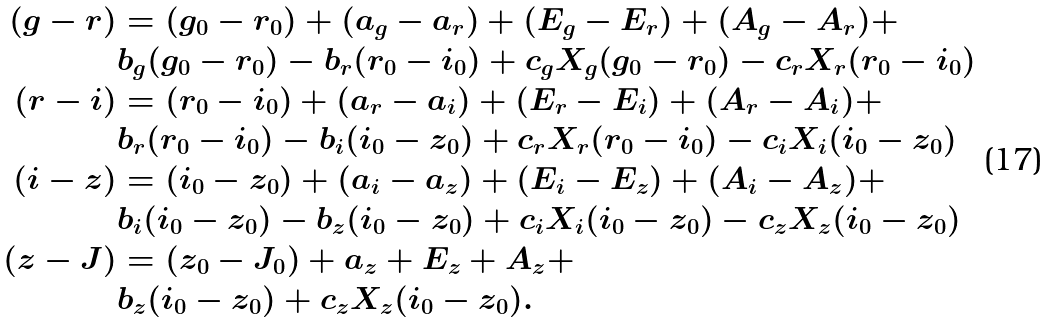Convert formula to latex. <formula><loc_0><loc_0><loc_500><loc_500>( g - r ) & = ( g _ { 0 } - r _ { 0 } ) + ( a _ { g } - a _ { r } ) + ( E _ { g } - E _ { r } ) + ( A _ { g } - A _ { r } ) + \\ & b _ { g } ( g _ { 0 } - r _ { 0 } ) - b _ { r } ( r _ { 0 } - i _ { 0 } ) + c _ { g } X _ { g } ( g _ { 0 } - r _ { 0 } ) - c _ { r } X _ { r } ( r _ { 0 } - i _ { 0 } ) \\ ( r - i ) & = ( r _ { 0 } - i _ { 0 } ) + ( a _ { r } - a _ { i } ) + ( E _ { r } - E _ { i } ) + ( A _ { r } - A _ { i } ) + \\ & b _ { r } ( r _ { 0 } - i _ { 0 } ) - b _ { i } ( i _ { 0 } - z _ { 0 } ) + c _ { r } X _ { r } ( r _ { 0 } - i _ { 0 } ) - c _ { i } X _ { i } ( i _ { 0 } - z _ { 0 } ) \\ ( i - z ) & = ( i _ { 0 } - z _ { 0 } ) + ( a _ { i } - a _ { z } ) + ( E _ { i } - E _ { z } ) + ( A _ { i } - A _ { z } ) + \\ & b _ { i } ( i _ { 0 } - z _ { 0 } ) - b _ { z } ( i _ { 0 } - z _ { 0 } ) + c _ { i } X _ { i } ( i _ { 0 } - z _ { 0 } ) - c _ { z } X _ { z } ( i _ { 0 } - z _ { 0 } ) \\ ( z - J ) & = ( z _ { 0 } - J _ { 0 } ) + a _ { z } + E _ { z } + A _ { z } + \\ & b _ { z } ( i _ { 0 } - z _ { 0 } ) + c _ { z } X _ { z } ( i _ { 0 } - z _ { 0 } ) .</formula> 